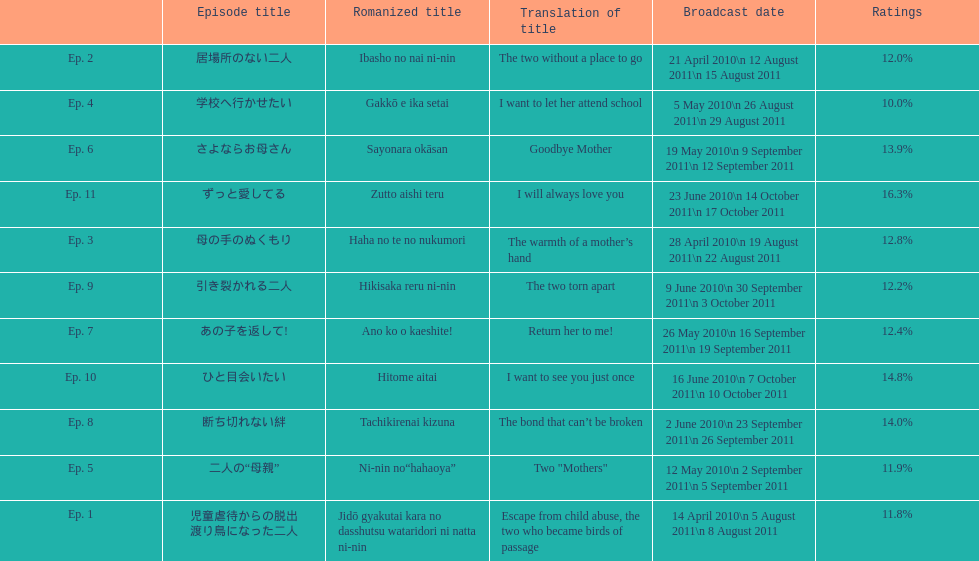How many episode total are there? 11. Help me parse the entirety of this table. {'header': ['', 'Episode title', 'Romanized title', 'Translation of title', 'Broadcast date', 'Ratings'], 'rows': [['Ep. 2', '居場所のない二人', 'Ibasho no nai ni-nin', 'The two without a place to go', '21 April 2010\\n 12 August 2011\\n 15 August 2011', '12.0%'], ['Ep. 4', '学校へ行かせたい', 'Gakkō e ika setai', 'I want to let her attend school', '5 May 2010\\n 26 August 2011\\n 29 August 2011', '10.0%'], ['Ep. 6', 'さよならお母さん', 'Sayonara okāsan', 'Goodbye Mother', '19 May 2010\\n 9 September 2011\\n 12 September 2011', '13.9%'], ['Ep. 11', 'ずっと愛してる', 'Zutto aishi teru', 'I will always love you', '23 June 2010\\n 14 October 2011\\n 17 October 2011', '16.3%'], ['Ep. 3', '母の手のぬくもり', 'Haha no te no nukumori', 'The warmth of a mother’s hand', '28 April 2010\\n 19 August 2011\\n 22 August 2011', '12.8%'], ['Ep. 9', '引き裂かれる二人', 'Hikisaka reru ni-nin', 'The two torn apart', '9 June 2010\\n 30 September 2011\\n 3 October 2011', '12.2%'], ['Ep. 7', 'あの子を返して!', 'Ano ko o kaeshite!', 'Return her to me!', '26 May 2010\\n 16 September 2011\\n 19 September 2011', '12.4%'], ['Ep. 10', 'ひと目会いたい', 'Hitome aitai', 'I want to see you just once', '16 June 2010\\n 7 October 2011\\n 10 October 2011', '14.8%'], ['Ep. 8', '断ち切れない絆', 'Tachikirenai kizuna', 'The bond that can’t be broken', '2 June 2010\\n 23 September 2011\\n 26 September 2011', '14.0%'], ['Ep. 5', '二人の“母親”', 'Ni-nin no“hahaoya”', 'Two "Mothers"', '12 May 2010\\n 2 September 2011\\n 5 September 2011', '11.9%'], ['Ep. 1', '児童虐待からの脱出 渡り鳥になった二人', 'Jidō gyakutai kara no dasshutsu wataridori ni natta ni-nin', 'Escape from child abuse, the two who became birds of passage', '14 April 2010\\n 5 August 2011\\n 8 August 2011', '11.8%']]} 